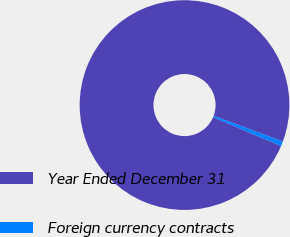<chart> <loc_0><loc_0><loc_500><loc_500><pie_chart><fcel>Year Ended December 31<fcel>Foreign currency contracts<nl><fcel>99.26%<fcel>0.74%<nl></chart> 